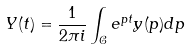<formula> <loc_0><loc_0><loc_500><loc_500>Y ( t ) = \frac { 1 } { 2 \pi i } \int _ { { \mathcal { C } } } e ^ { p t } y ( p ) d p</formula> 